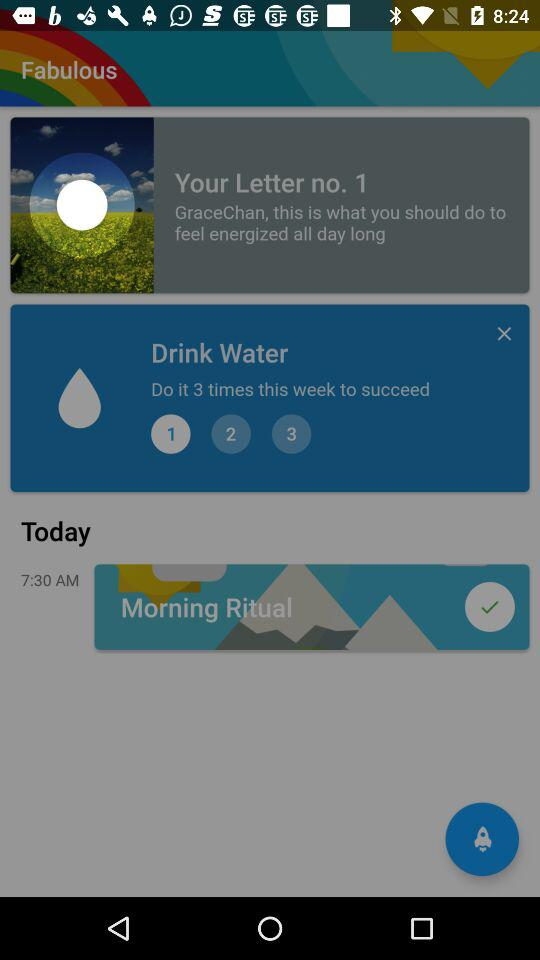How many times do I need to do the task?
Answer the question using a single word or phrase. 3 